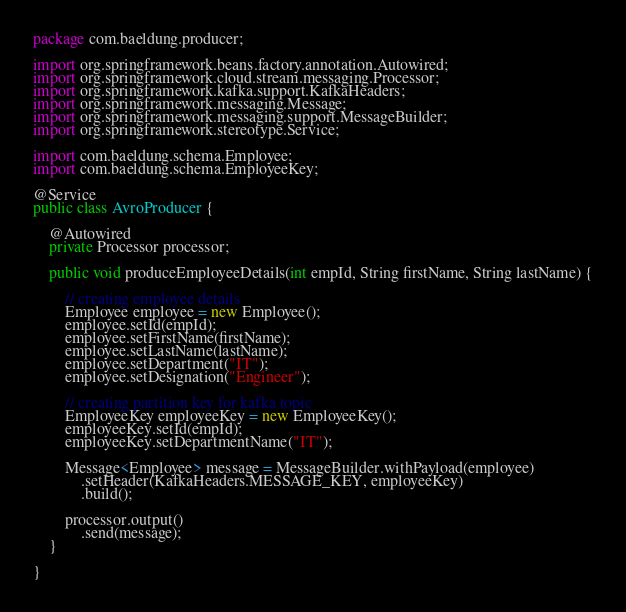Convert code to text. <code><loc_0><loc_0><loc_500><loc_500><_Java_>package com.baeldung.producer;

import org.springframework.beans.factory.annotation.Autowired;
import org.springframework.cloud.stream.messaging.Processor;
import org.springframework.kafka.support.KafkaHeaders;
import org.springframework.messaging.Message;
import org.springframework.messaging.support.MessageBuilder;
import org.springframework.stereotype.Service;

import com.baeldung.schema.Employee;
import com.baeldung.schema.EmployeeKey;

@Service
public class AvroProducer {

    @Autowired
    private Processor processor;

    public void produceEmployeeDetails(int empId, String firstName, String lastName) {

        // creating employee details
        Employee employee = new Employee();
        employee.setId(empId);
        employee.setFirstName(firstName);
        employee.setLastName(lastName);
        employee.setDepartment("IT");
        employee.setDesignation("Engineer");

        // creating partition key for kafka topic
        EmployeeKey employeeKey = new EmployeeKey();
        employeeKey.setId(empId);
        employeeKey.setDepartmentName("IT");

        Message<Employee> message = MessageBuilder.withPayload(employee)
            .setHeader(KafkaHeaders.MESSAGE_KEY, employeeKey)
            .build();

        processor.output()
            .send(message);
    }

}
</code> 